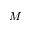<formula> <loc_0><loc_0><loc_500><loc_500>M</formula> 